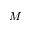<formula> <loc_0><loc_0><loc_500><loc_500>M</formula> 